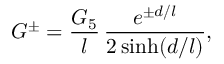<formula> <loc_0><loc_0><loc_500><loc_500>G ^ { \pm } = \frac { G _ { 5 } } l \, \frac { e ^ { \pm d / l } } { 2 \sinh ( d / l ) } ,</formula> 